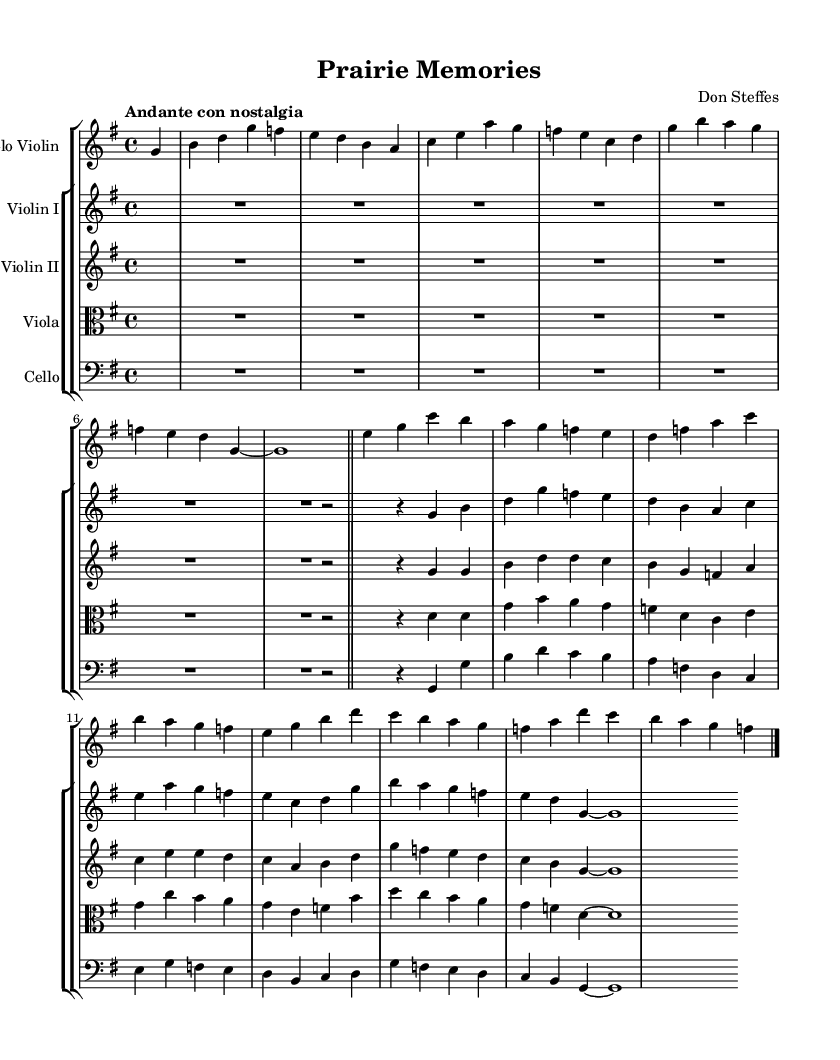What is the key signature of this music? The key signature is indicated at the beginning of the sheet music, showing one sharp, which signifies that the piece is in G major.
Answer: G major What is the time signature of this music? The time signature is located at the beginning of the sheet music, displaying 4 over 4, which indicates a common time signature allowing for four beats per measure.
Answer: 4/4 What is the tempo marking of this piece? The tempo marking is found at the top of the sheet music, stating "Andante con nostalgia," which suggests a moderate, reflective pace that evokes a sense of nostalgia.
Answer: Andante con nostalgia How many measures are in the excerpt for solo violin? By counting the measures in the solo violin part, we see that there are eight measures before the double bar, indicating the end of that section.
Answer: 8 Which instruments accompany the solo violin? Upon review of the score layout, the accompanying instruments include Violin I, Violin II, Viola, and Cello, which together create a string ensemble.
Answer: Violin I, Violin II, Viola, Cello What musical element is predominantly featured in the piece? Analyzing the melodic content, it becomes clear that the piece heavily features lyrical and flowing melodic lines, characteristic of Romantic music, meant to evoke emotion and memory.
Answer: Lyrical melodies What is the overall mood conveyed by the music? By interpreting the tempo, key, and style indicated within the score, the overall mood can be described as nostalgic and reflective, aiming to capture the essence of rural Midwestern landscapes.
Answer: Nostalgic 